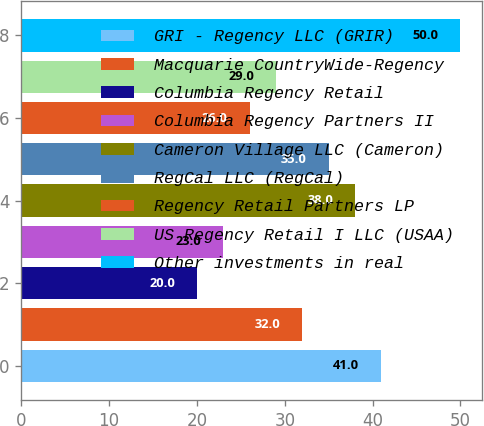Convert chart to OTSL. <chart><loc_0><loc_0><loc_500><loc_500><bar_chart><fcel>GRI - Regency LLC (GRIR)<fcel>Macquarie CountryWide-Regency<fcel>Columbia Regency Retail<fcel>Columbia Regency Partners II<fcel>Cameron Village LLC (Cameron)<fcel>RegCal LLC (RegCal)<fcel>Regency Retail Partners LP<fcel>US Regency Retail I LLC (USAA)<fcel>Other investments in real<nl><fcel>41<fcel>32<fcel>20<fcel>23<fcel>38<fcel>35<fcel>26<fcel>29<fcel>50<nl></chart> 